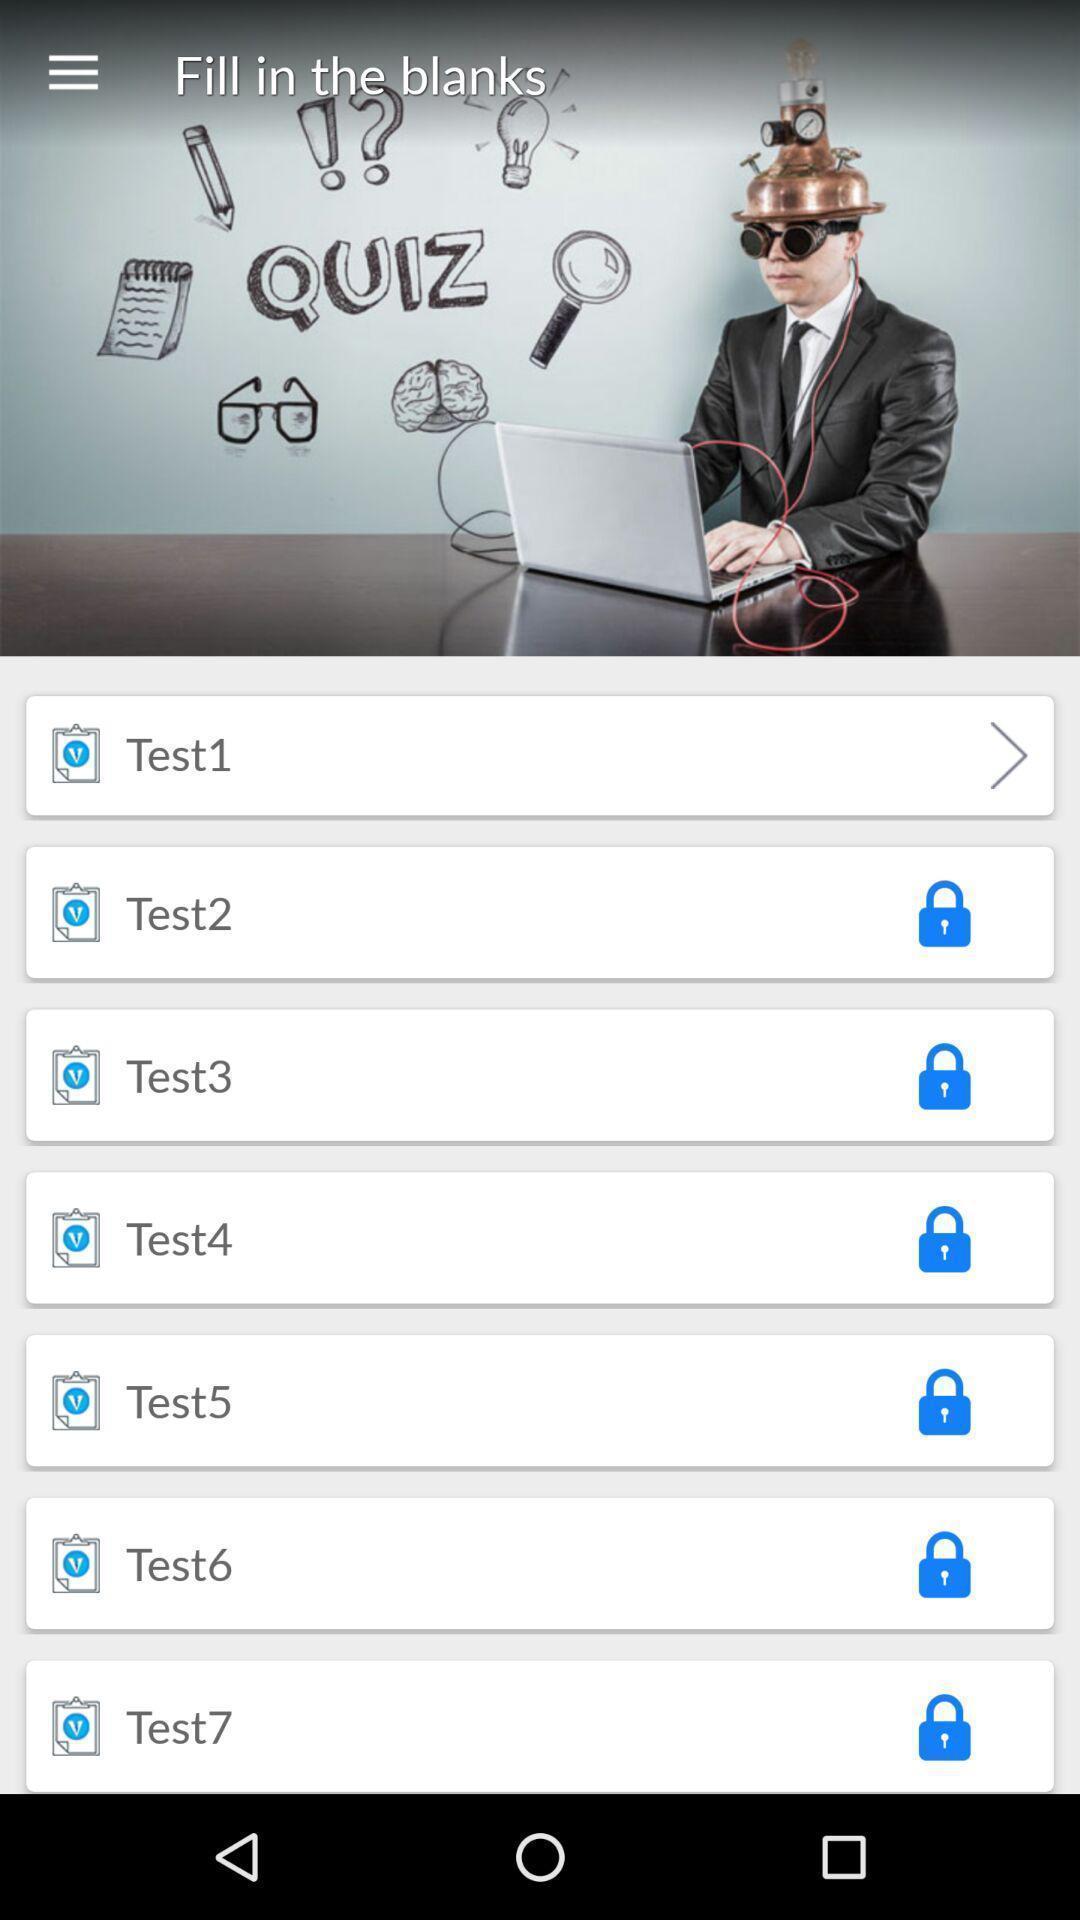Describe this image in words. Screen shows list of options in a learning app. 